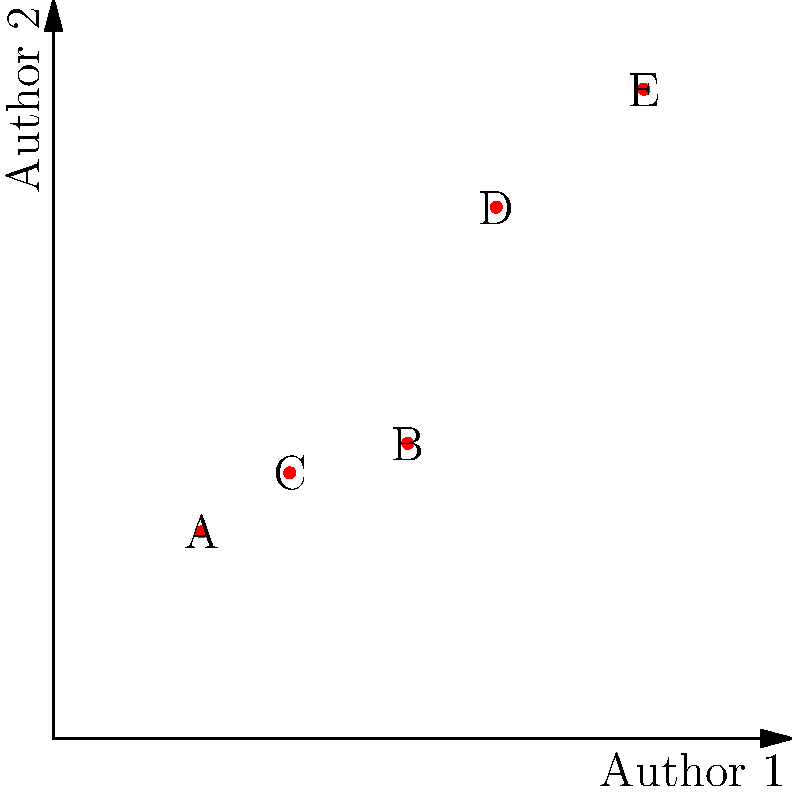Analyze the scatter plot comparing word usage frequency between two authors. Which point represents the greatest difference in word usage between Author 1 and Author 2, and what is the magnitude of this difference? To find the point with the greatest difference in word usage and calculate its magnitude:

1. Identify the coordinates for each point:
   A: (5, 7)
   B: (12, 10)
   C: (8, 9)
   D: (15, 18)
   E: (20, 22)

2. Calculate the difference between Author 2 and Author 1 for each point:
   A: 7 - 5 = 2
   B: 10 - 12 = -2
   C: 9 - 8 = 1
   D: 18 - 15 = 3
   E: 22 - 20 = 2

3. Find the largest absolute difference:
   The largest absolute difference is 3, corresponding to point D.

4. Determine the magnitude:
   The magnitude is the absolute value of the difference, which is 3.

Therefore, point D represents the greatest difference in word usage between Author 1 and Author 2, with a magnitude of 3.
Answer: Point D, magnitude 3 